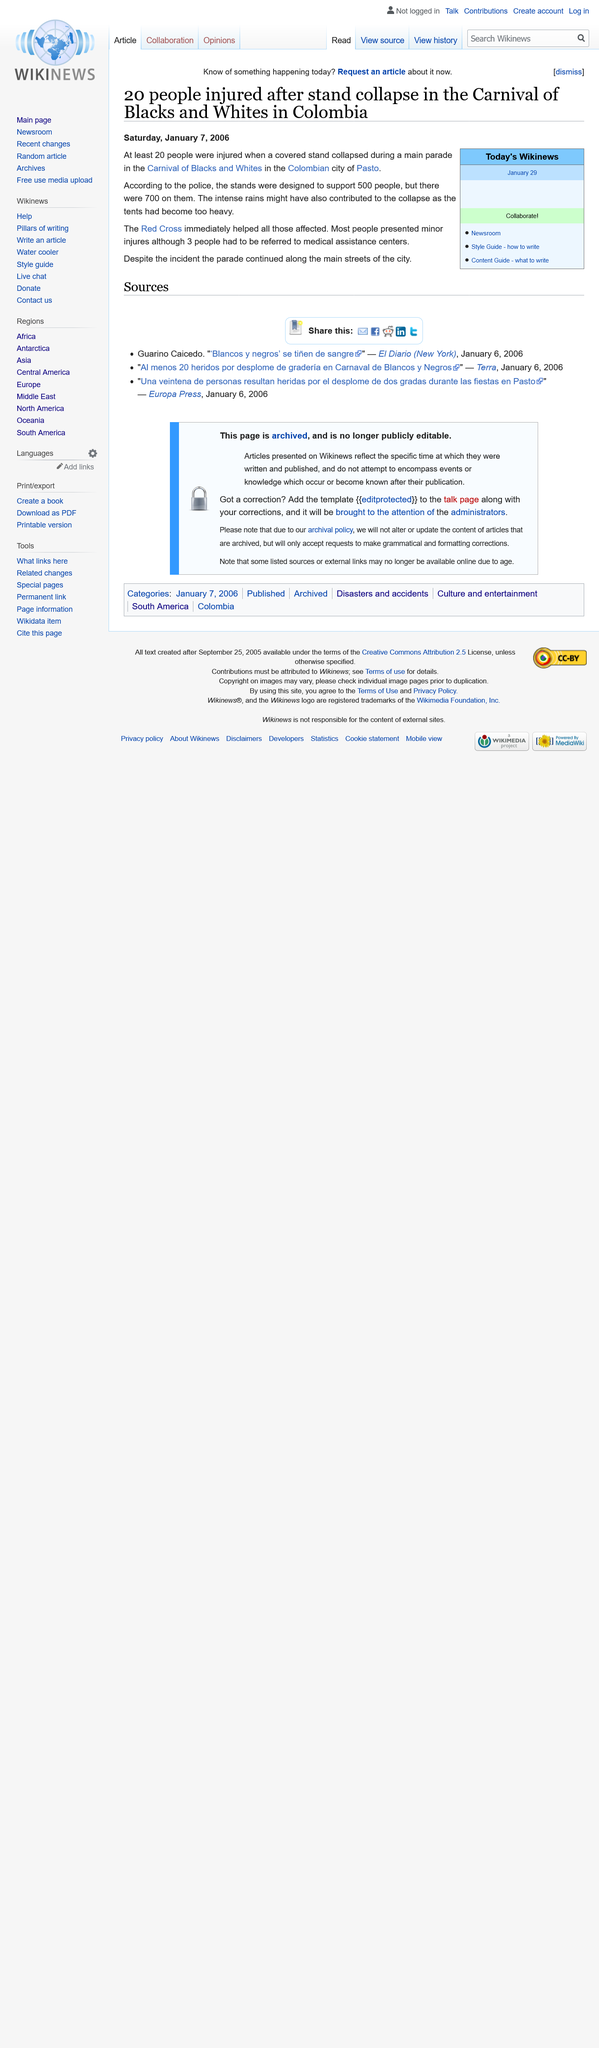Identify some key points in this picture. At least 20 individuals sustained injuries when a stand crumbled, and the number of casualties is expected to increase as rescue operations continue. The stands were designed to support 500 people, with the capacity to hold a large crowd. In total, 20 individuals sustained injuries, and of those 3 required transportation to medical assistance centres for further treatment. 